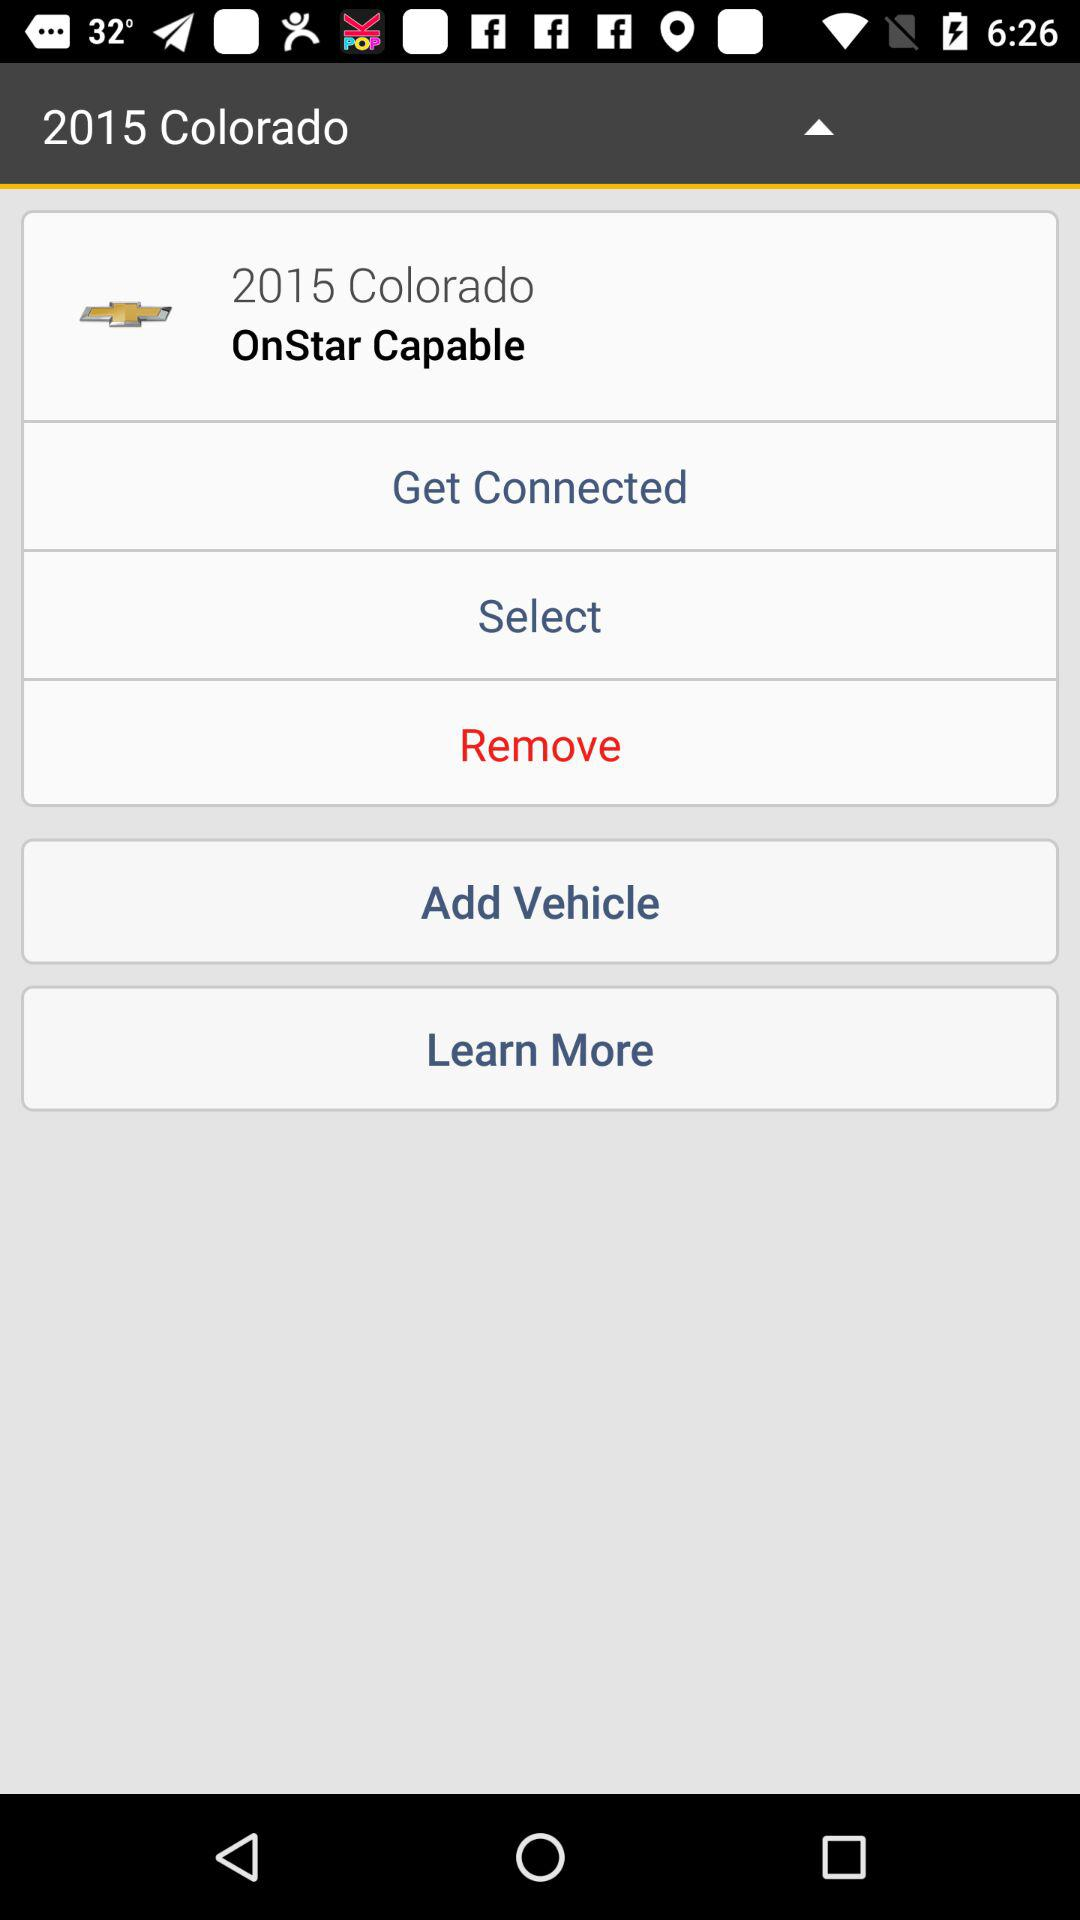What is the year and the mentioned place? The year is 2015 and the place is Colorado. 